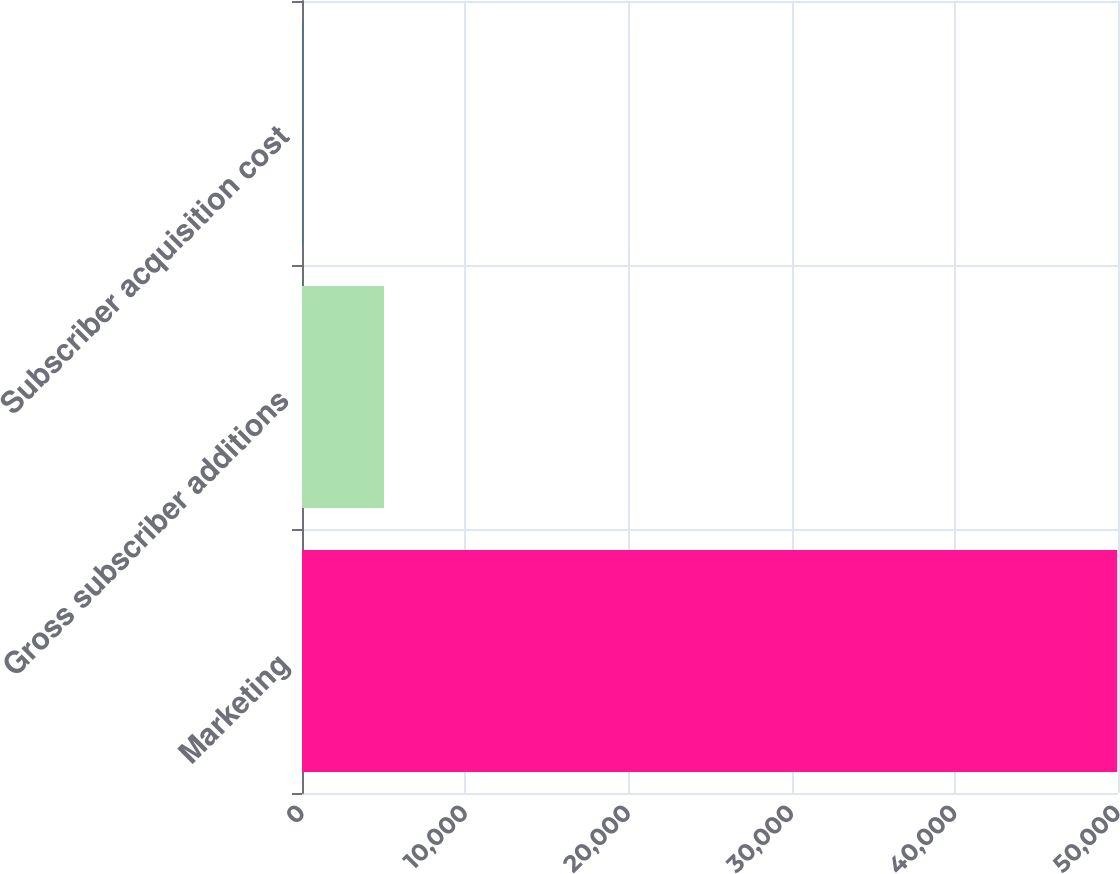<chart> <loc_0><loc_0><loc_500><loc_500><bar_chart><fcel>Marketing<fcel>Gross subscriber additions<fcel>Subscriber acquisition cost<nl><fcel>49949<fcel>5023.51<fcel>31.79<nl></chart> 